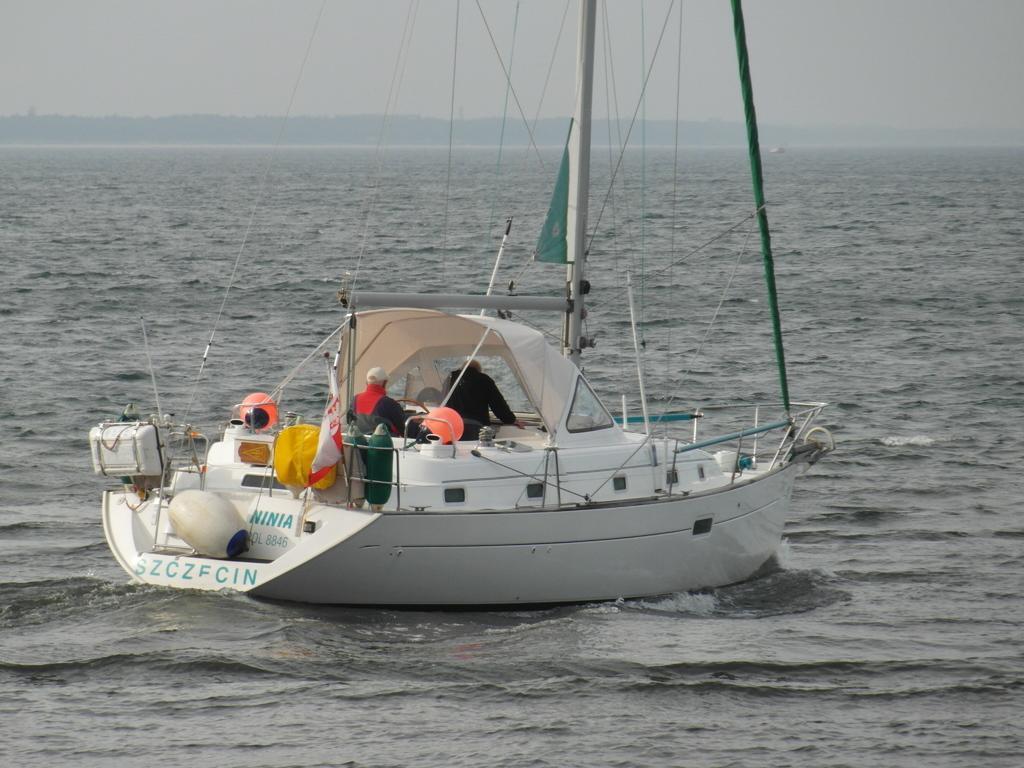Could you give a brief overview of what you see in this image? In this picture there is a white boat on the water. In the background I can see the mountains and ocean. At the top there is a sky. In that boat I can see two person were sitting on the chair. 